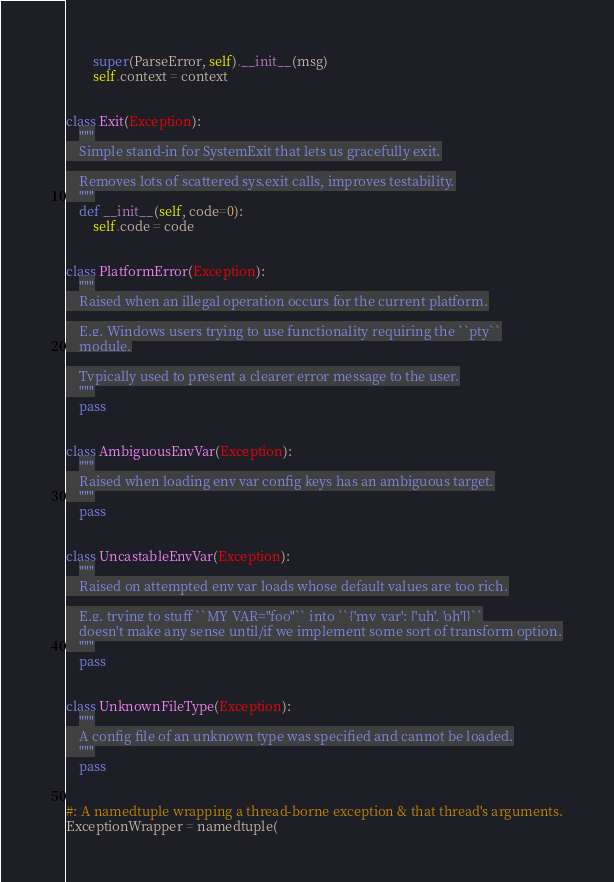Convert code to text. <code><loc_0><loc_0><loc_500><loc_500><_Python_>        super(ParseError, self).__init__(msg)
        self.context = context


class Exit(Exception):
    """
    Simple stand-in for SystemExit that lets us gracefully exit.

    Removes lots of scattered sys.exit calls, improves testability.
    """
    def __init__(self, code=0):
        self.code = code


class PlatformError(Exception):
    """
    Raised when an illegal operation occurs for the current platform.

    E.g. Windows users trying to use functionality requiring the ``pty``
    module.

    Typically used to present a clearer error message to the user.
    """
    pass


class AmbiguousEnvVar(Exception):
    """
    Raised when loading env var config keys has an ambiguous target.
    """
    pass


class UncastableEnvVar(Exception):
    """
    Raised on attempted env var loads whose default values are too rich.

    E.g. trying to stuff ``MY_VAR="foo"`` into ``{'my_var': ['uh', 'oh']}``
    doesn't make any sense until/if we implement some sort of transform option.
    """
    pass


class UnknownFileType(Exception):
    """
    A config file of an unknown type was specified and cannot be loaded.
    """
    pass


#: A namedtuple wrapping a thread-borne exception & that thread's arguments.
ExceptionWrapper = namedtuple(</code> 